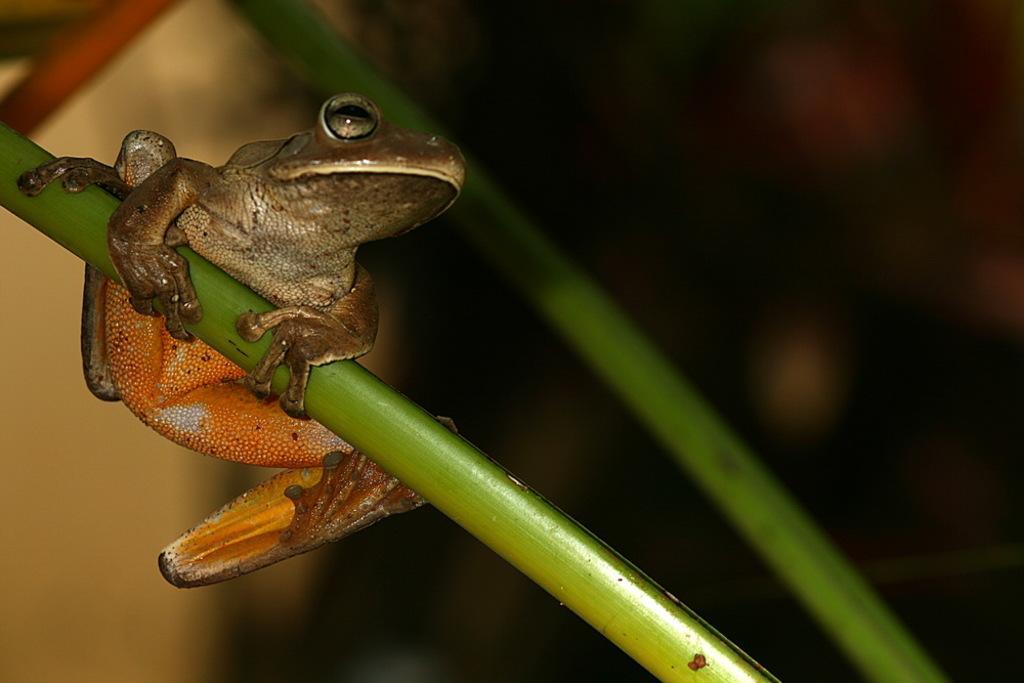Could you give a brief overview of what you see in this image? On the left side of this image there is a frog on a stem. Beside this there is another stem. The background is blurred. 